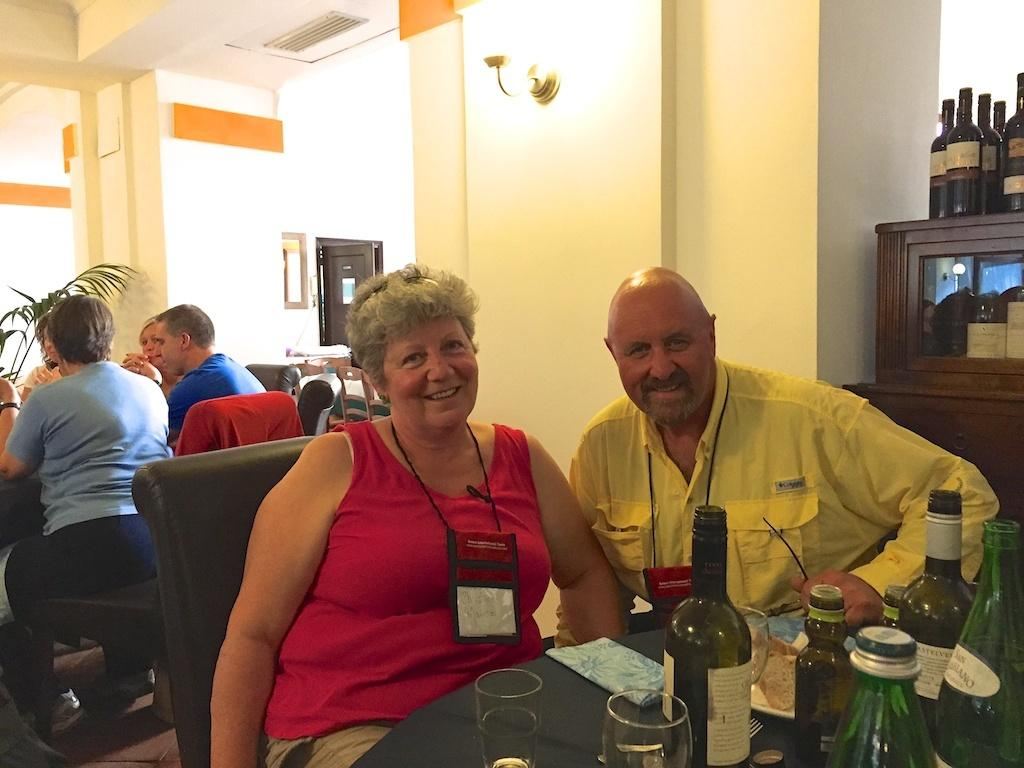How many people are sitting on the chair in the image? There are two persons sitting on a chair in the image. What is in front of the two persons sitting on the chair? There is a table in front of them. What can be found on the table in the image? The table has drinks on it. Can you describe the people sitting behind the two persons on the chair? There is a group of people sitting behind the two persons. What type of jellyfish can be seen swimming in the drinks on the table? There are no jellyfish present in the image; the table has drinks on it, but no jellyfish are visible. 